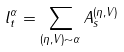<formula> <loc_0><loc_0><loc_500><loc_500>l _ { t } ^ { \alpha } = \sum _ { ( \eta , V ) \sim \alpha } A _ { s } ^ { ( \eta , V ) }</formula> 